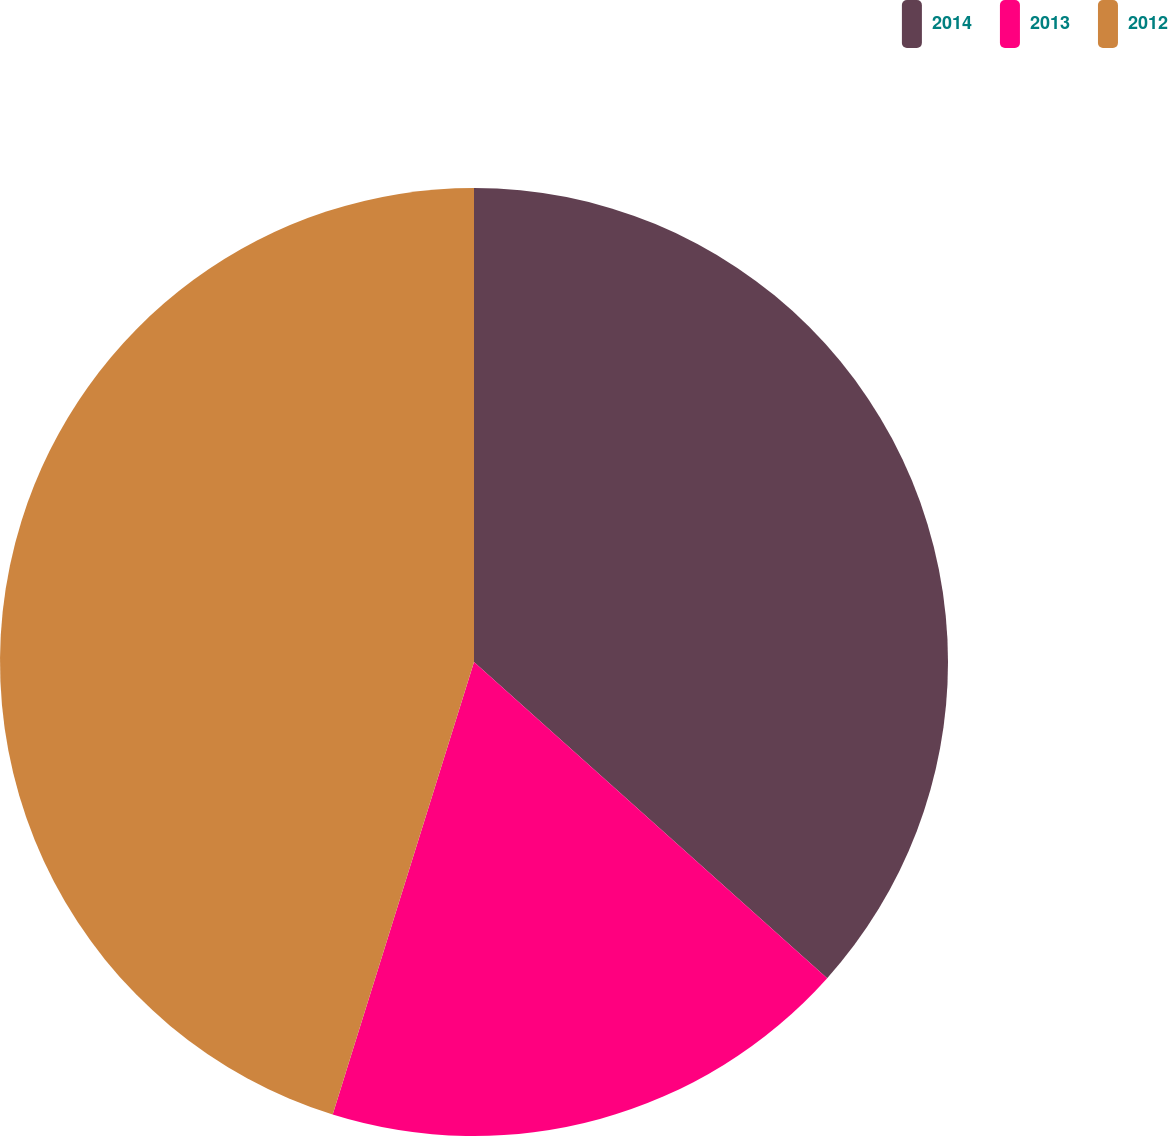<chart> <loc_0><loc_0><loc_500><loc_500><pie_chart><fcel>2014<fcel>2013<fcel>2012<nl><fcel>36.62%<fcel>18.2%<fcel>45.18%<nl></chart> 